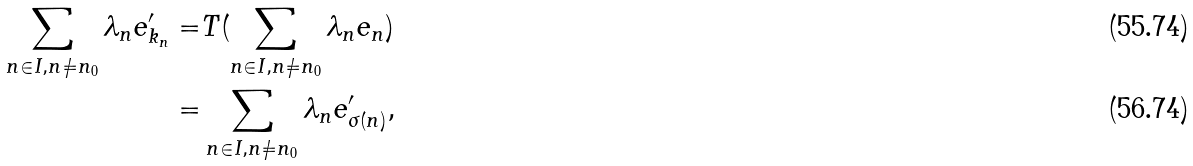Convert formula to latex. <formula><loc_0><loc_0><loc_500><loc_500>\sum _ { n \in I , n \neq n _ { 0 } } \lambda _ { n } e ^ { \prime } _ { k _ { n } } = & T ( \sum _ { n \in I , n \neq n _ { 0 } } \lambda _ { n } e _ { n } ) \\ = & \sum _ { n \in I , n \neq n _ { 0 } } \lambda _ { n } e ^ { \prime } _ { \sigma ( n ) } ,</formula> 